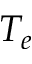<formula> <loc_0><loc_0><loc_500><loc_500>T _ { e }</formula> 